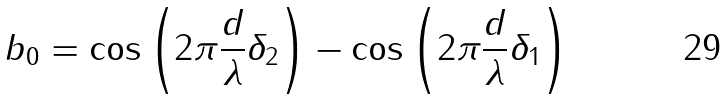<formula> <loc_0><loc_0><loc_500><loc_500>b _ { 0 } = \cos \left ( 2 \pi \frac { d } { \lambda } \delta _ { 2 } \right ) - \cos \left ( 2 \pi \frac { d } { \lambda } \delta _ { 1 } \right )</formula> 